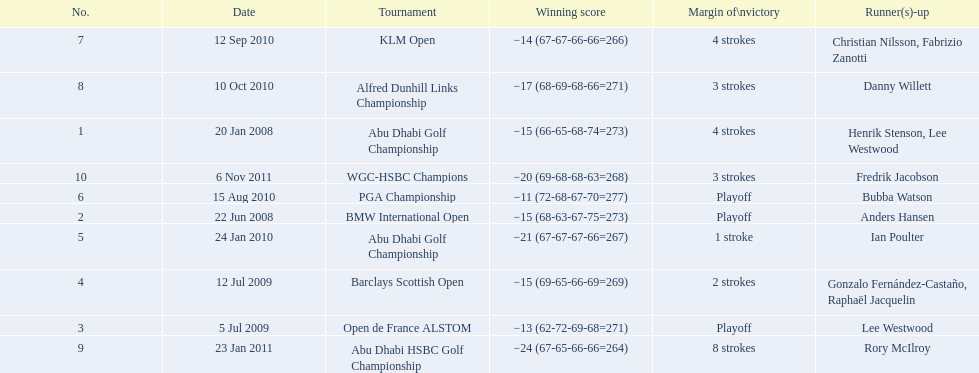Which tournaments did martin kaymer participate in? Abu Dhabi Golf Championship, BMW International Open, Open de France ALSTOM, Barclays Scottish Open, Abu Dhabi Golf Championship, PGA Championship, KLM Open, Alfred Dunhill Links Championship, Abu Dhabi HSBC Golf Championship, WGC-HSBC Champions. How many of these tournaments were won through a playoff? BMW International Open, Open de France ALSTOM, PGA Championship. Which of those tournaments took place in 2010? PGA Championship. Who had to top score next to martin kaymer for that tournament? Bubba Watson. 